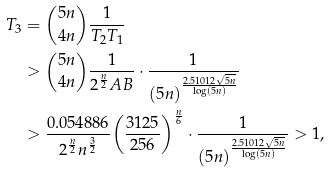Convert formula to latex. <formula><loc_0><loc_0><loc_500><loc_500>{ T _ { 3 } } & = \binom { 5 n } { 4 n } \frac { 1 } { { T _ { 2 } } { T _ { 1 } } } \\ & > \binom { 5 n } { 4 n } \frac { 1 } { 2 ^ { \frac { n } { 2 } } A B } \cdot \frac { 1 } { { ( 5 n ) } ^ { \frac { 2 . 5 1 0 1 2 \sqrt { 5 n } } { \log ( 5 n ) } } } \\ & > \frac { 0 . 0 5 4 8 8 6 } { 2 ^ { \frac { n } { 2 } } n ^ { \frac { 3 } { 2 } } } { \left ( \frac { 3 1 2 5 } { 2 5 6 } \right ) } ^ { \frac { n } { 6 } } \cdot \frac { 1 } { { ( 5 n ) } ^ { \frac { 2 . 5 1 0 1 2 \sqrt { 5 n } } { \log ( 5 n ) } } } > 1 ,</formula> 